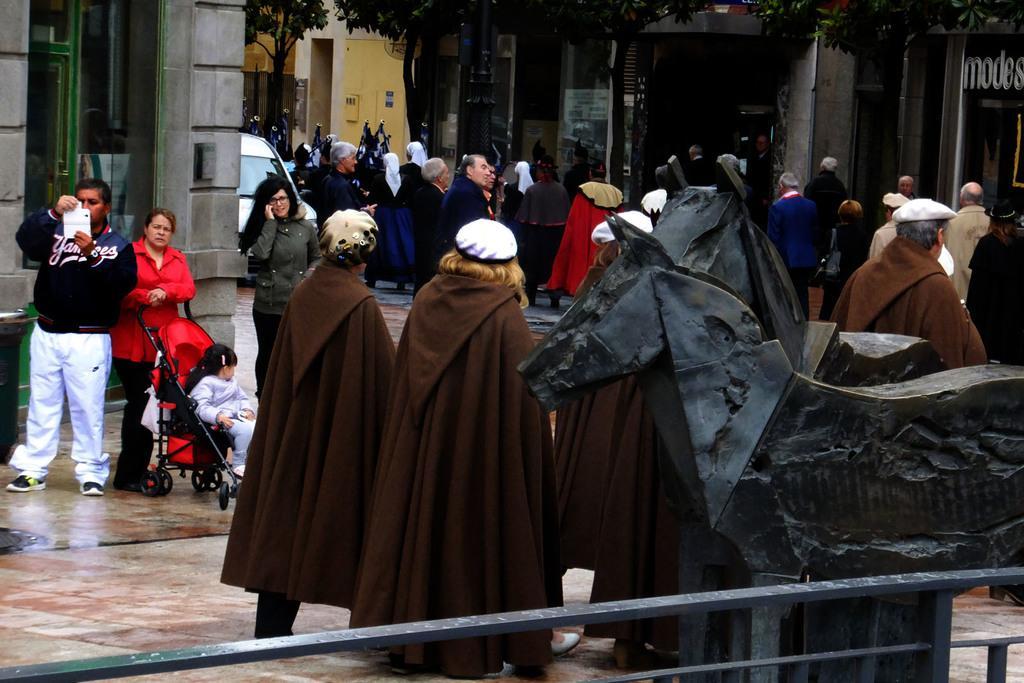How would you summarize this image in a sentence or two? In this image, there are groups of people standing. At the bottom of the image, I can see an iron grill. There are two statues of the animals, which are behind an iron grill. In the background, I can see the trees and buildings. There is a car, which is behind a building. On the left side of the image, I can see a stroller with a kid sitting in it. 